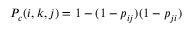<formula> <loc_0><loc_0><loc_500><loc_500>P _ { c } ( i , k , j ) = 1 - ( 1 - p _ { i j } ) ( 1 - p _ { j i } )</formula> 